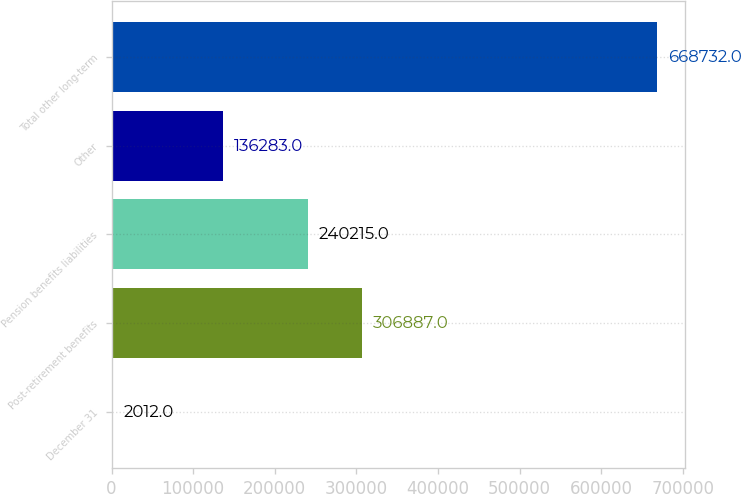Convert chart to OTSL. <chart><loc_0><loc_0><loc_500><loc_500><bar_chart><fcel>December 31<fcel>Post-retirement benefits<fcel>Pension benefits liabilities<fcel>Other<fcel>Total other long-term<nl><fcel>2012<fcel>306887<fcel>240215<fcel>136283<fcel>668732<nl></chart> 